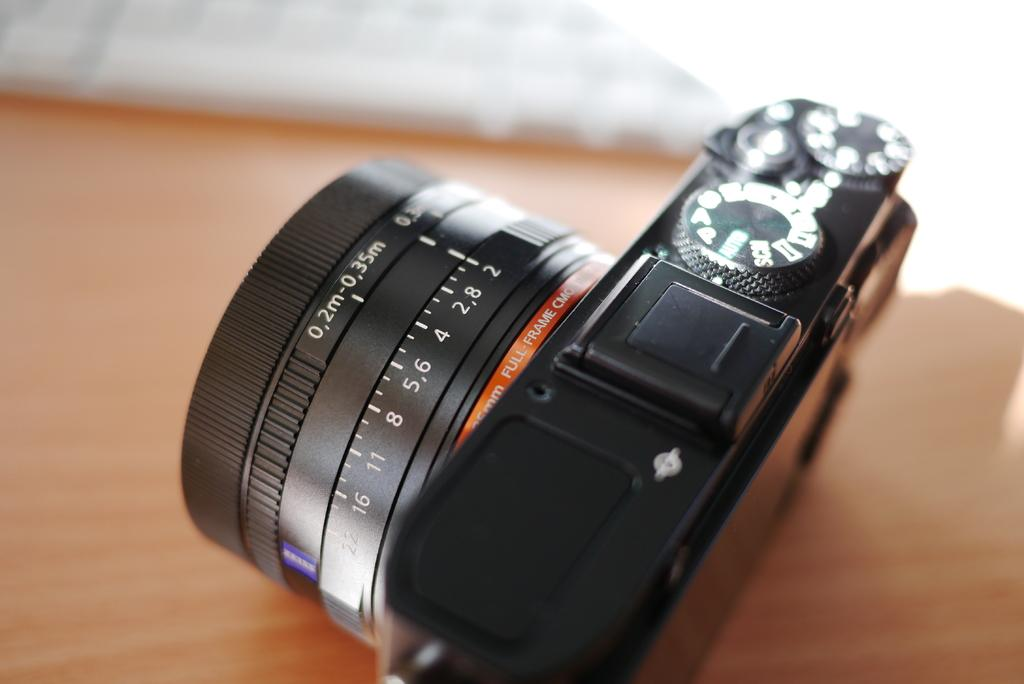<image>
Write a terse but informative summary of the picture. Black camera which has the measurement of 0.2m on it. 